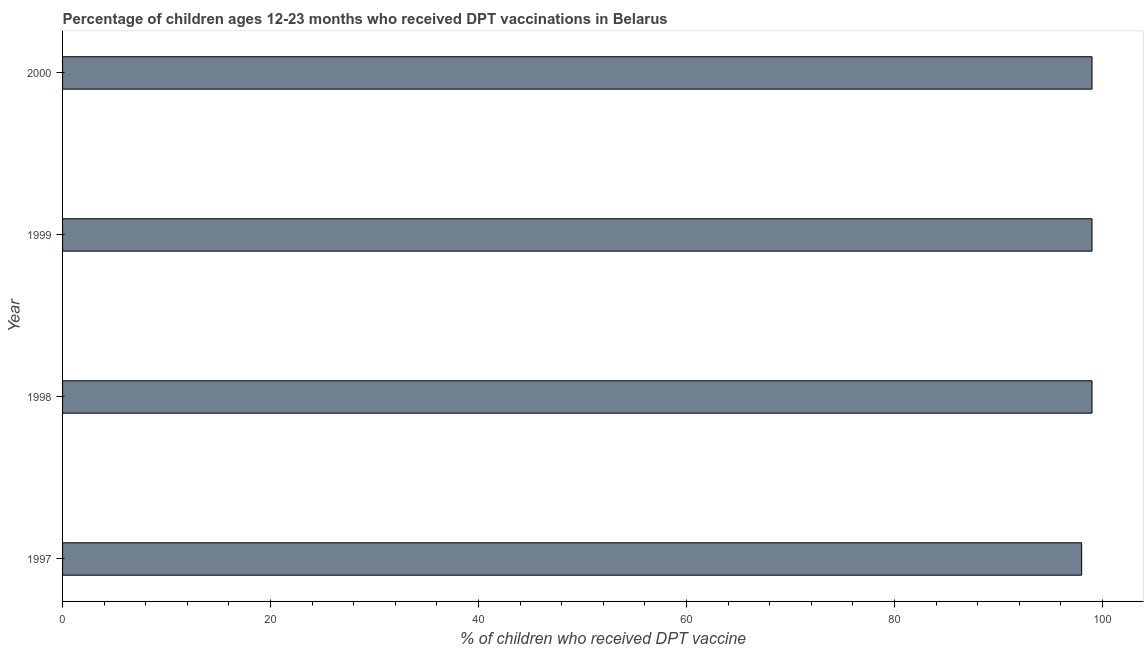Does the graph contain grids?
Give a very brief answer. No. What is the title of the graph?
Give a very brief answer. Percentage of children ages 12-23 months who received DPT vaccinations in Belarus. What is the label or title of the X-axis?
Give a very brief answer. % of children who received DPT vaccine. What is the label or title of the Y-axis?
Keep it short and to the point. Year. What is the percentage of children who received dpt vaccine in 1999?
Ensure brevity in your answer.  99. Across all years, what is the maximum percentage of children who received dpt vaccine?
Your response must be concise. 99. Across all years, what is the minimum percentage of children who received dpt vaccine?
Ensure brevity in your answer.  98. In which year was the percentage of children who received dpt vaccine maximum?
Offer a very short reply. 1998. What is the sum of the percentage of children who received dpt vaccine?
Provide a succinct answer. 395. What is the difference between the percentage of children who received dpt vaccine in 1997 and 2000?
Provide a succinct answer. -1. What is the average percentage of children who received dpt vaccine per year?
Offer a very short reply. 98. Do a majority of the years between 1998 and 2000 (inclusive) have percentage of children who received dpt vaccine greater than 12 %?
Keep it short and to the point. Yes. What is the ratio of the percentage of children who received dpt vaccine in 1997 to that in 2000?
Provide a short and direct response. 0.99. Is the percentage of children who received dpt vaccine in 1997 less than that in 1999?
Ensure brevity in your answer.  Yes. Is the difference between the percentage of children who received dpt vaccine in 1997 and 1998 greater than the difference between any two years?
Offer a very short reply. Yes. What is the difference between the highest and the second highest percentage of children who received dpt vaccine?
Offer a very short reply. 0. How many bars are there?
Offer a very short reply. 4. How many years are there in the graph?
Your answer should be compact. 4. What is the difference between two consecutive major ticks on the X-axis?
Your answer should be compact. 20. Are the values on the major ticks of X-axis written in scientific E-notation?
Your response must be concise. No. What is the % of children who received DPT vaccine in 1999?
Make the answer very short. 99. What is the % of children who received DPT vaccine of 2000?
Offer a terse response. 99. What is the difference between the % of children who received DPT vaccine in 1997 and 1998?
Offer a very short reply. -1. What is the difference between the % of children who received DPT vaccine in 1998 and 1999?
Give a very brief answer. 0. What is the difference between the % of children who received DPT vaccine in 1998 and 2000?
Give a very brief answer. 0. What is the difference between the % of children who received DPT vaccine in 1999 and 2000?
Give a very brief answer. 0. What is the ratio of the % of children who received DPT vaccine in 1997 to that in 1999?
Ensure brevity in your answer.  0.99. What is the ratio of the % of children who received DPT vaccine in 1998 to that in 1999?
Provide a short and direct response. 1. 